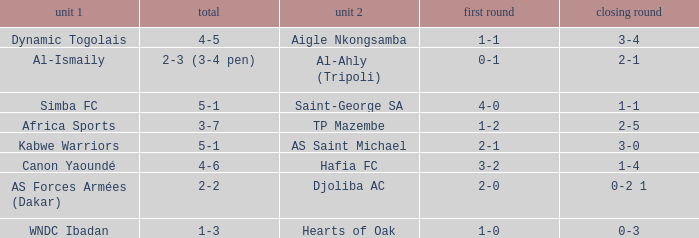What was the 2nd leg result in the match that scored a 2-0 in the 1st leg? 0-2 1. 